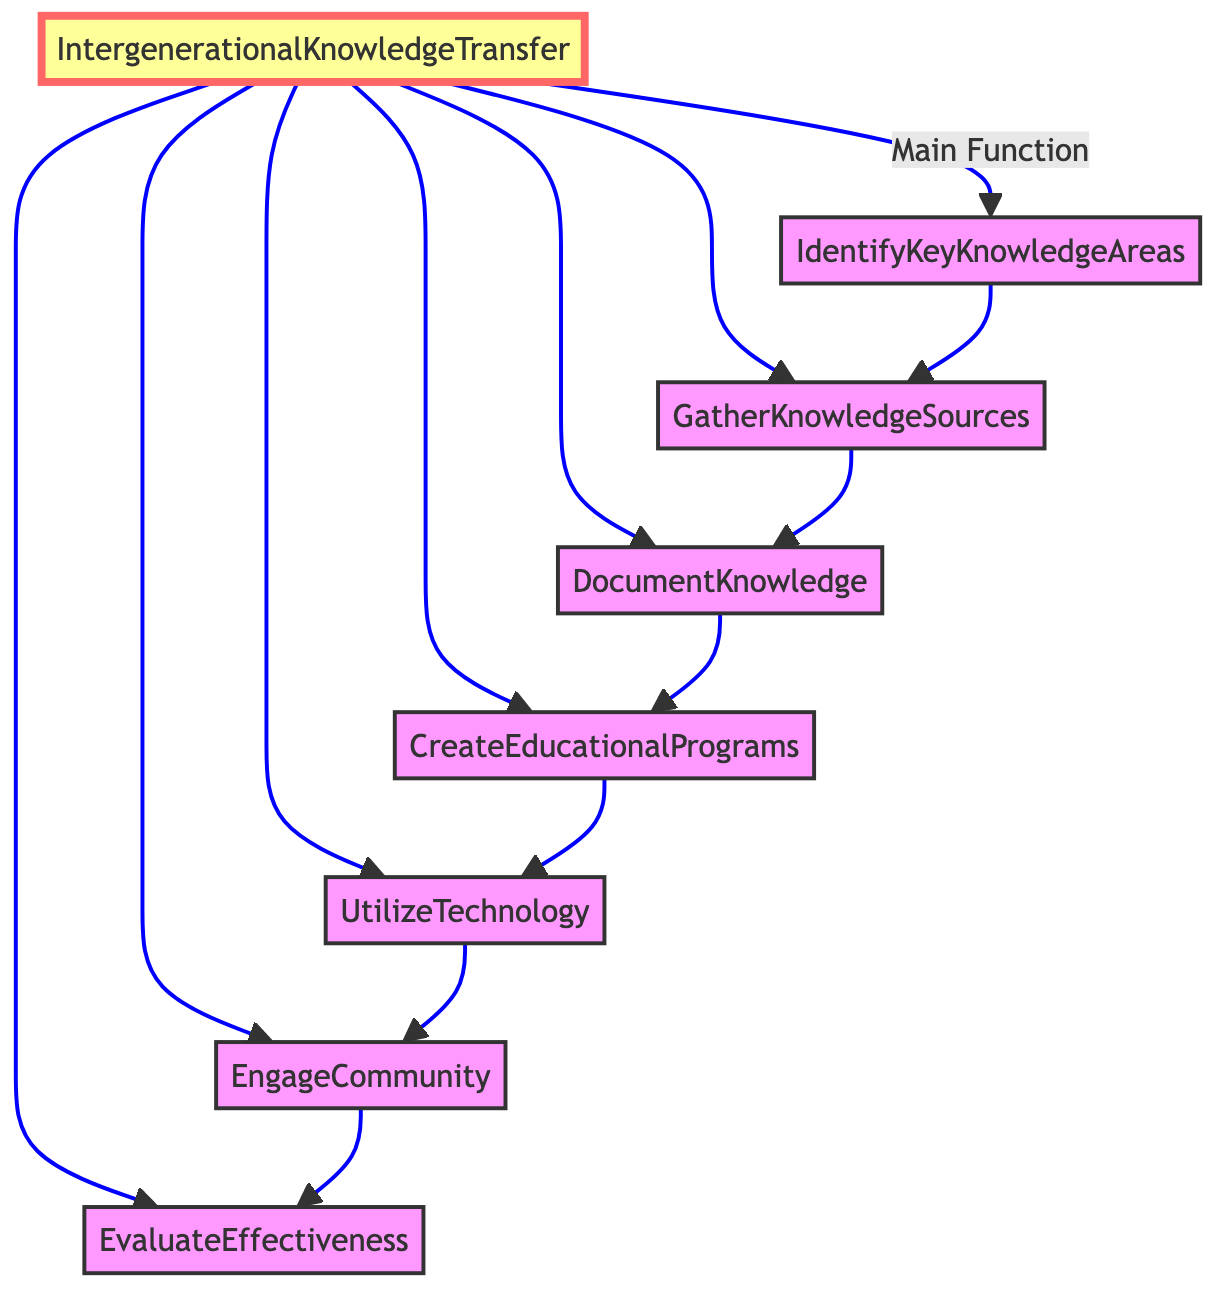What is the main function in this flowchart? The main function is at the top of the flowchart and is titled "IntergenerationalKnowledgeTransfer", indicating it's the primary focus of the diagram.
Answer: IntergenerationalKnowledgeTransfer How many total functions are represented in the diagram? Counting all the nodes labeled as functions, there are a total of seven functions listed.
Answer: 7 Which function comes after "GatherKnowledgeSources"? The flowchart illustrates that "GatherKnowledgeSources" leads directly to "DocumentKnowledge," indicating the sequential flow from one function to the next.
Answer: DocumentKnowledge What is the purpose of the "CreateEducationalPrograms" function? Looking at the description next to "CreateEducationalPrograms," it outlines the design and implementation of sessions and workshops, serving as a method for disseminating knowledge.
Answer: Design and implement programs for knowledge dissemination Which function is the last step in the knowledge transfer process? The last step in the flowchart, following the flow of functions, is "EvaluateEffectiveness", which assesses the impact of previous functions.
Answer: EvaluateEffectiveness How does "UtilizeTechnology" relate to "EngageCommunity"? "UtilizeTechnology" is a function that comes before "EngageCommunity" in the flow, indicating that technology should be used before engaging the community in activities.
Answer: It precedes it in the process What is the first function in the knowledge transfer process? The first function in the flowchart is "IdentifyKeyKnowledgeAreas", as it is the initial step for the knowledge transfer process.
Answer: IdentifyKeyKnowledgeAreas How many functions are linked directly to the main function? Observing the flowchart, the main function "IntergenerationalKnowledgeTransfer" connects directly to six different functions listed below it.
Answer: 6 